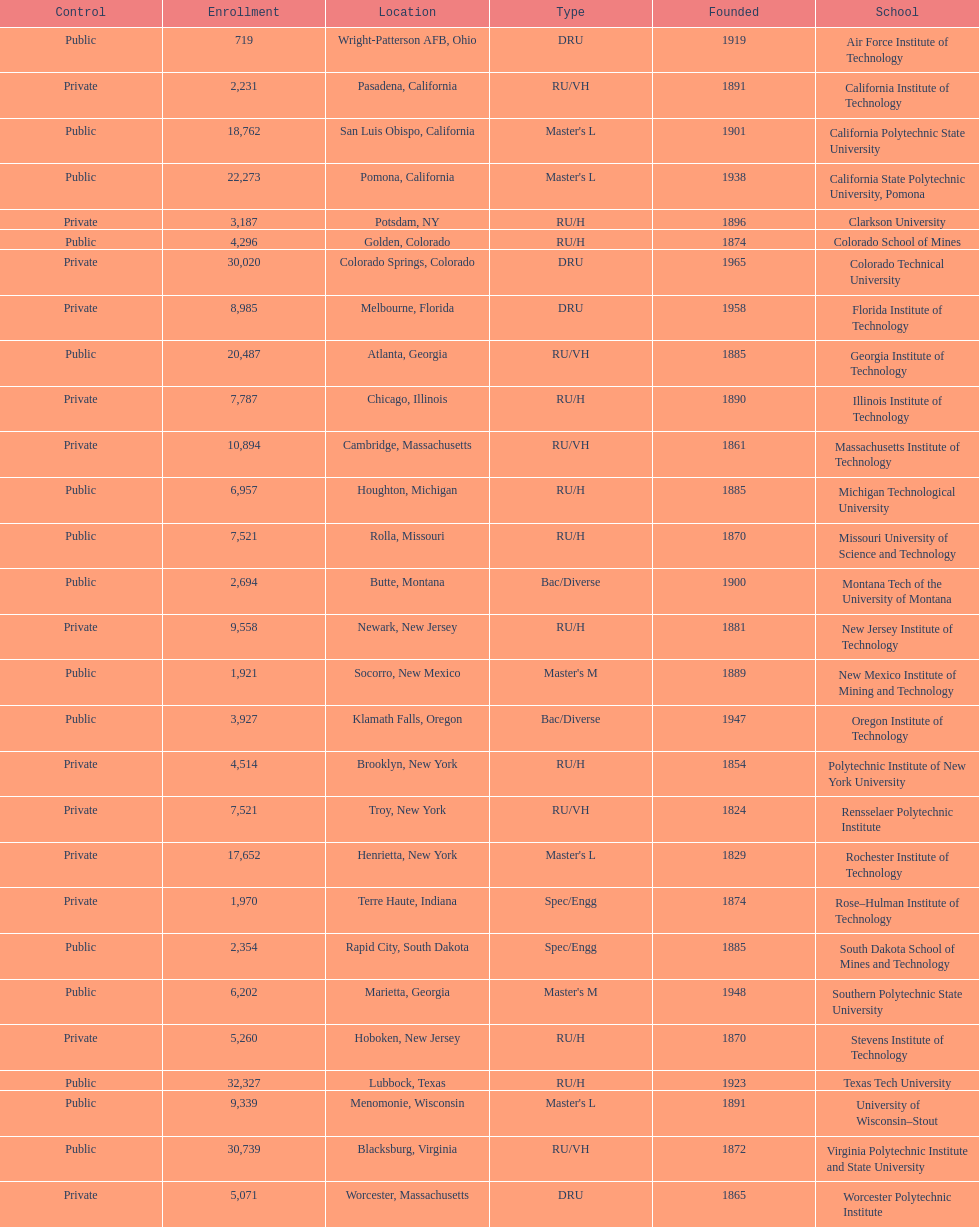How many technological institutions are there in california, usa? 3. Parse the full table. {'header': ['Control', 'Enrollment', 'Location', 'Type', 'Founded', 'School'], 'rows': [['Public', '719', 'Wright-Patterson AFB, Ohio', 'DRU', '1919', 'Air Force Institute of Technology'], ['Private', '2,231', 'Pasadena, California', 'RU/VH', '1891', 'California Institute of Technology'], ['Public', '18,762', 'San Luis Obispo, California', "Master's L", '1901', 'California Polytechnic State University'], ['Public', '22,273', 'Pomona, California', "Master's L", '1938', 'California State Polytechnic University, Pomona'], ['Private', '3,187', 'Potsdam, NY', 'RU/H', '1896', 'Clarkson University'], ['Public', '4,296', 'Golden, Colorado', 'RU/H', '1874', 'Colorado School of Mines'], ['Private', '30,020', 'Colorado Springs, Colorado', 'DRU', '1965', 'Colorado Technical University'], ['Private', '8,985', 'Melbourne, Florida', 'DRU', '1958', 'Florida Institute of Technology'], ['Public', '20,487', 'Atlanta, Georgia', 'RU/VH', '1885', 'Georgia Institute of Technology'], ['Private', '7,787', 'Chicago, Illinois', 'RU/H', '1890', 'Illinois Institute of Technology'], ['Private', '10,894', 'Cambridge, Massachusetts', 'RU/VH', '1861', 'Massachusetts Institute of Technology'], ['Public', '6,957', 'Houghton, Michigan', 'RU/H', '1885', 'Michigan Technological University'], ['Public', '7,521', 'Rolla, Missouri', 'RU/H', '1870', 'Missouri University of Science and Technology'], ['Public', '2,694', 'Butte, Montana', 'Bac/Diverse', '1900', 'Montana Tech of the University of Montana'], ['Private', '9,558', 'Newark, New Jersey', 'RU/H', '1881', 'New Jersey Institute of Technology'], ['Public', '1,921', 'Socorro, New Mexico', "Master's M", '1889', 'New Mexico Institute of Mining and Technology'], ['Public', '3,927', 'Klamath Falls, Oregon', 'Bac/Diverse', '1947', 'Oregon Institute of Technology'], ['Private', '4,514', 'Brooklyn, New York', 'RU/H', '1854', 'Polytechnic Institute of New York University'], ['Private', '7,521', 'Troy, New York', 'RU/VH', '1824', 'Rensselaer Polytechnic Institute'], ['Private', '17,652', 'Henrietta, New York', "Master's L", '1829', 'Rochester Institute of Technology'], ['Private', '1,970', 'Terre Haute, Indiana', 'Spec/Engg', '1874', 'Rose–Hulman Institute of Technology'], ['Public', '2,354', 'Rapid City, South Dakota', 'Spec/Engg', '1885', 'South Dakota School of Mines and Technology'], ['Public', '6,202', 'Marietta, Georgia', "Master's M", '1948', 'Southern Polytechnic State University'], ['Private', '5,260', 'Hoboken, New Jersey', 'RU/H', '1870', 'Stevens Institute of Technology'], ['Public', '32,327', 'Lubbock, Texas', 'RU/H', '1923', 'Texas Tech University'], ['Public', '9,339', 'Menomonie, Wisconsin', "Master's L", '1891', 'University of Wisconsin–Stout'], ['Public', '30,739', 'Blacksburg, Virginia', 'RU/VH', '1872', 'Virginia Polytechnic Institute and State University'], ['Private', '5,071', 'Worcester, Massachusetts', 'DRU', '1865', 'Worcester Polytechnic Institute']]} 